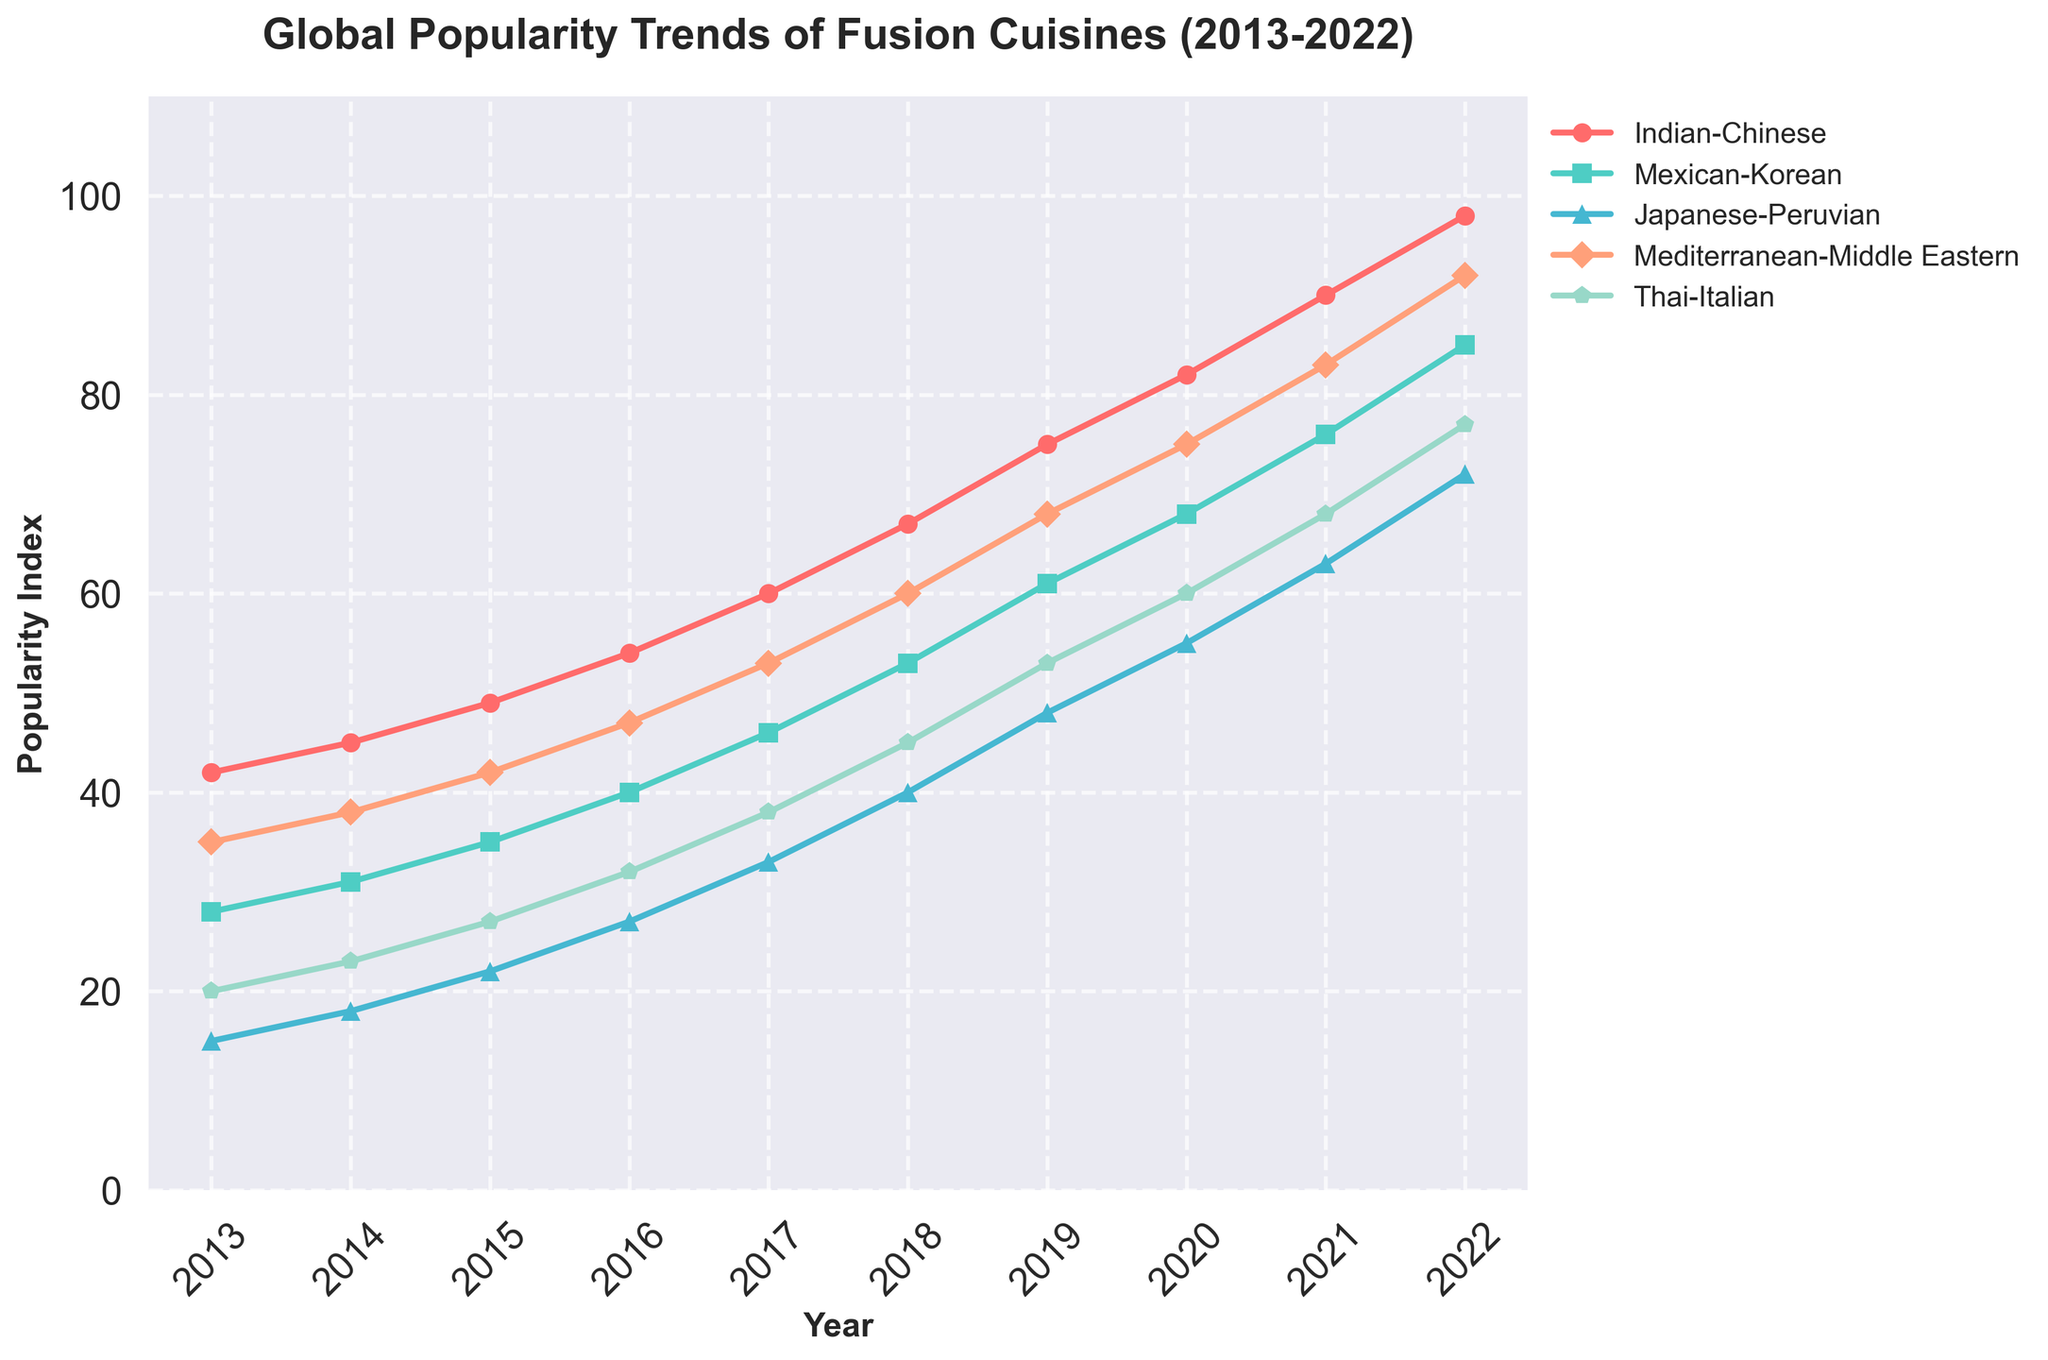How did the popularity of Japanese-Peruvian cuisine change from 2013 to 2017? Look at the values for Japanese-Peruvian cuisine in 2013 and 2017. The value in 2013 is 15, and in 2017 it is 33. Subtracting 15 from 33 gives the change.
Answer: 18 In 2020, which fusion cuisine saw the highest popularity index? Examine the values for all fusion cuisines in 2020. The highest value is 82 for Indian-Chinese cuisine.
Answer: Indian-Chinese By how much did the popularity index of Mexican-Korean cuisine increase from 2016 to 2022? Look at the values for Mexican-Korean cuisine in 2016 and 2022. The value in 2016 is 40, and in 2022 it is 85. Subtracting 40 from 85 gives the increase.
Answer: 45 Which two cuisines had the closest popularity indices in 2019, and what were their values? Look at the 2019 values for all cuisines. Mexican-Korean (61) and Thai-Italian (53) are the closest, separated by 8.
Answer: Mexican-Korean (61), Thai-Italian (53) What is the average popularity index of Mediterranean-Middle Eastern cuisine from 2013 to 2017? Sum the values from 2013 to 2017 (35 + 38 + 42 + 47 + 53) = 215, then divide by 5 (the number of years).
Answer: 43 In which year did Indian-Chinese cuisine surpass the popularity index of 80? Look at the values for Indian-Chinese cuisine to find the first year it exceeds 80. The value surpasses 80 in 2020.
Answer: 2020 Which cuisine showed the least growth in popularity from 2013 to 2022? Calculate the change in popularity for each cuisine from 2013 to 2022. The values are: Indian-Chinese (+56), Mexican-Korean (+57), Japanese-Peruvian (+57), Mediterranean-Middle Eastern (+57), Thai-Italian (+57). All cuisines except Indian-Chinese have the same growth; the smallest is for Indian-Chinese.
Answer: Indian-Chinese From 2013 to 2022, did any two cuisines have the same popularity index in the same year? Compare all popularity values year by year. No two cuisines share the same value in any year.
Answer: No 